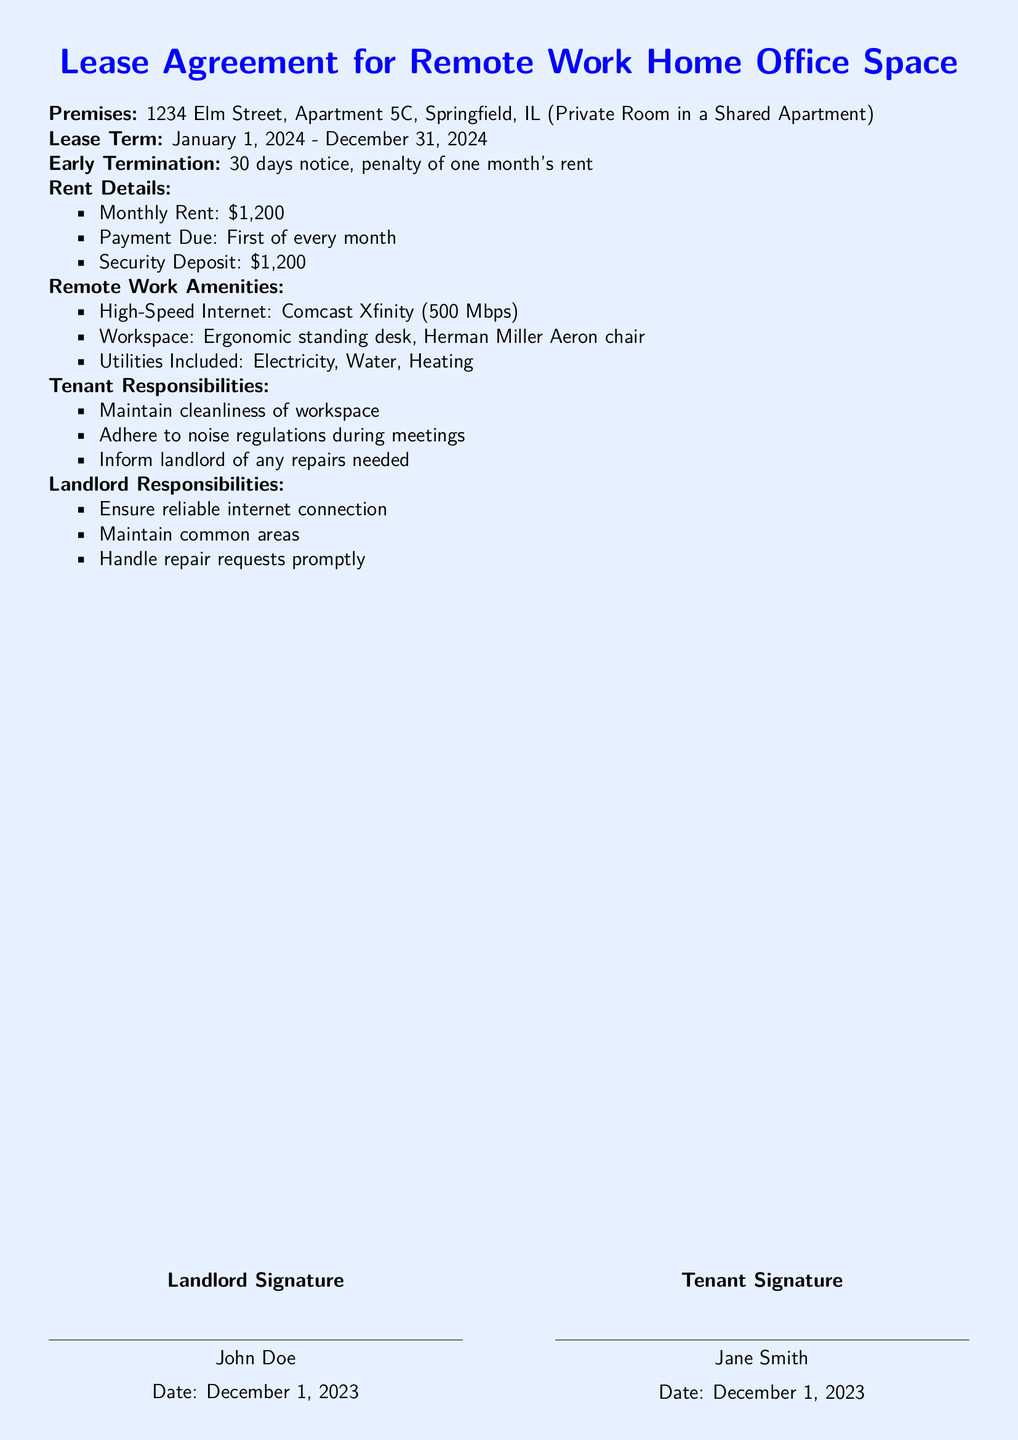What is the address of the leased premises? The address is clearly stated in the document under the premises section.
Answer: 1234 Elm Street, Apartment 5C, Springfield, IL What is the monthly rent amount? The monthly rent is specified in the rent details section of the document.
Answer: $1,200 What is the penalty for early termination? The penalty for early termination is mentioned in the early termination clause.
Answer: One month's rent What amenities are provided for remote work? The document lists various remote work amenities under a specific section.
Answer: High-Speed Internet, Workspace, Utilities Included What date does the lease begin? The start date of the lease is specified in the lease term section.
Answer: January 1, 2024 What responsibilities does the tenant have? Tenant responsibilities are listed in bullet points in the document.
Answer: Maintain cleanliness of workspace, Adhere to noise regulations during meetings, Inform landlord of any repairs needed What is the length of the lease term? The lease term duration is provided in the lease term section.
Answer: One year Who is the landlord? The landlord's name is mentioned at the end of the document under the signature section.
Answer: John Doe What type of office space is being leased? The type of office space is described in the premises section of the document.
Answer: Private Room in a Shared Apartment 